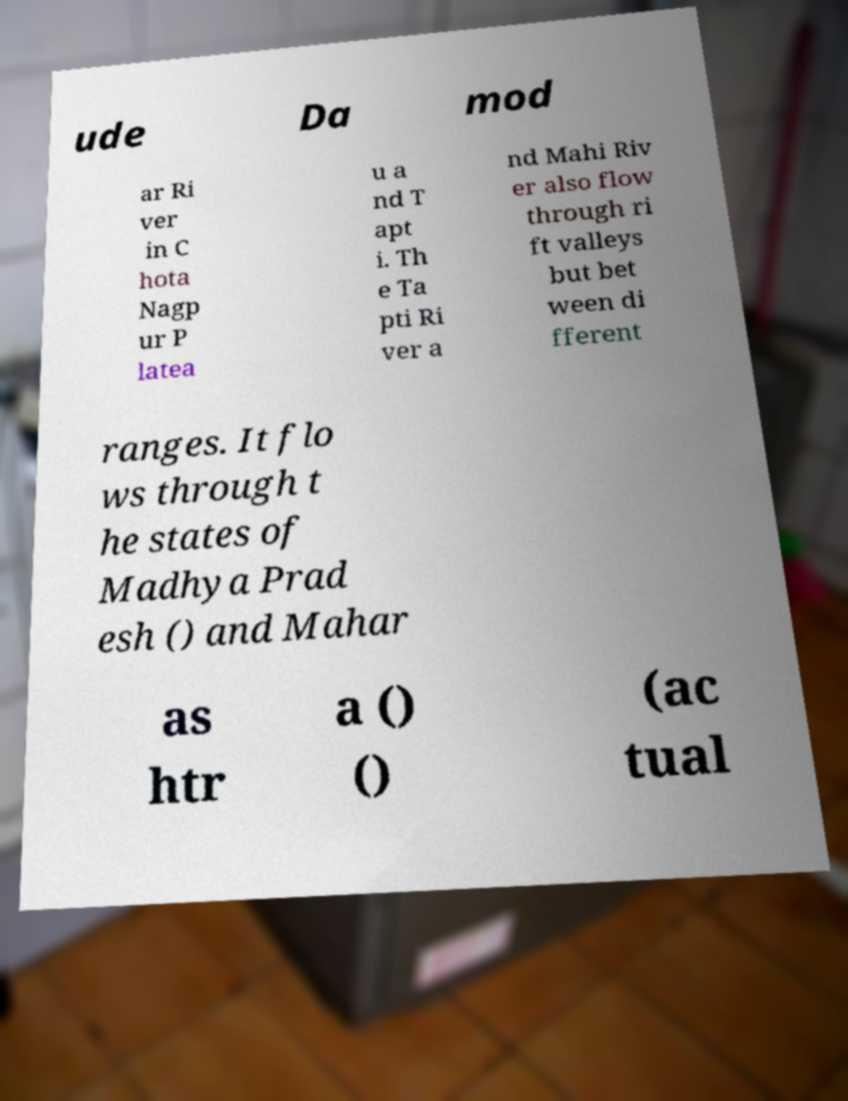Could you assist in decoding the text presented in this image and type it out clearly? ude Da mod ar Ri ver in C hota Nagp ur P latea u a nd T apt i. Th e Ta pti Ri ver a nd Mahi Riv er also flow through ri ft valleys but bet ween di fferent ranges. It flo ws through t he states of Madhya Prad esh () and Mahar as htr a () () (ac tual 